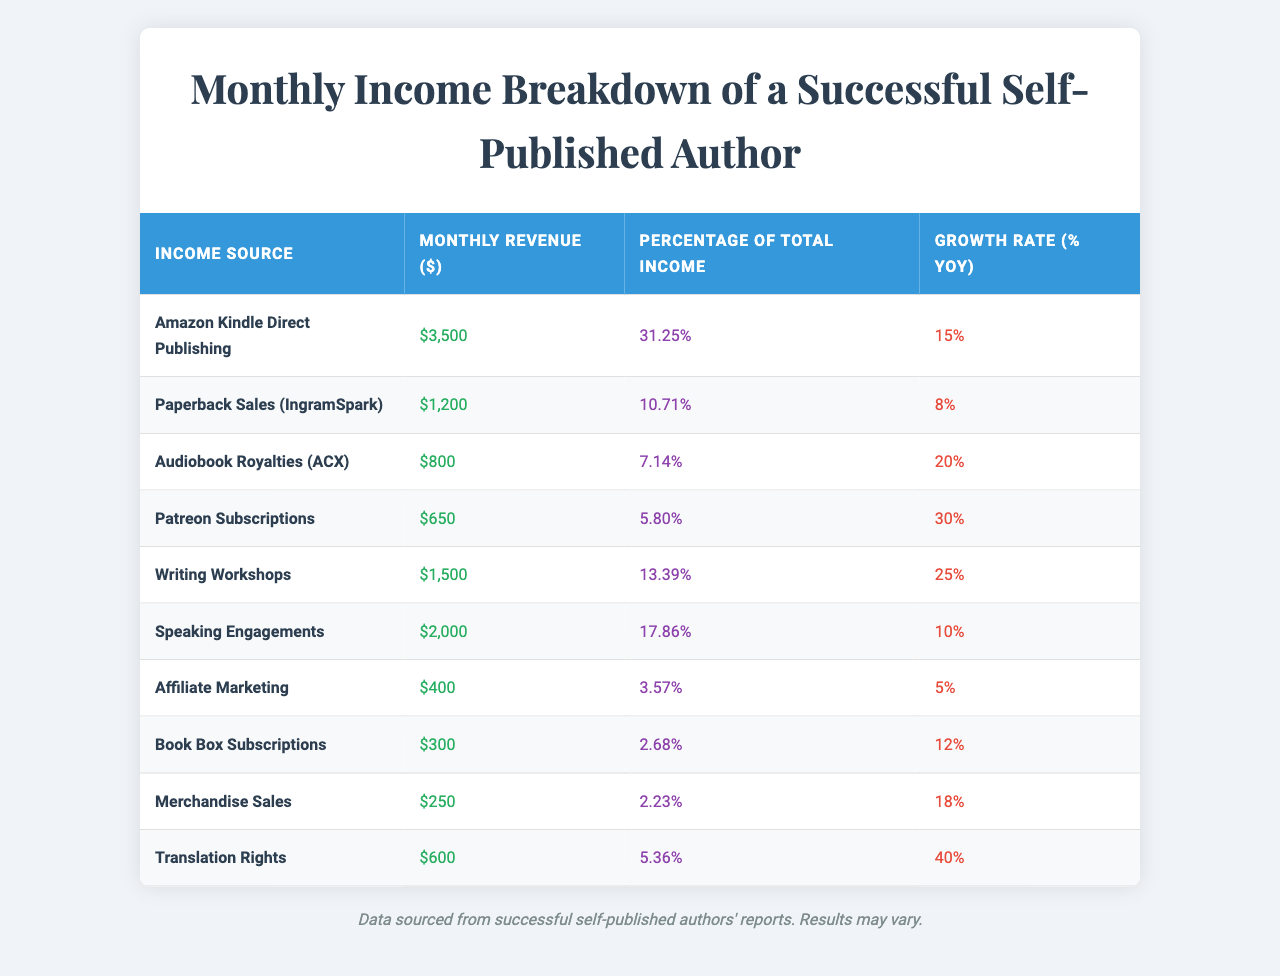What is the highest source of monthly revenue? The highest monthly revenue is listed under "Amazon Kindle Direct Publishing" with $3,500.
Answer: $3,500 What percentage of total income does "Speaking Engagements" represent? "Speaking Engagements" accounts for 17.86% of the total income.
Answer: 17.86% Which income source has the lowest monthly revenue? The income source with the lowest monthly revenue is "Translation Rights" at $600.
Answer: $600 What is the total monthly revenue from all sources? To find the total, we sum all monthly revenues: $3,500 + $1,200 + $800 + $650 + $1,500 + $2,000 + $400 + $300 + $250 + $600 = $12,200.
Answer: $12,200 Is the growth rate of "Patreon Subscriptions" higher than that of "Affiliate Marketing"? "Patreon Subscriptions" has a growth rate of 30%, while "Affiliate Marketing" has a rate of 5%. Thus, the statement is true.
Answer: Yes What is the average growth rate across all income sources? The average growth rate can be calculated by summing all growth rates: (15 + 8 + 20 + 30 + 25 + 10 + 5 + 12 + 18 + 40) =  188, and dividing by the number of sources (10): 188 / 10 = 18.8%.
Answer: 18.8% Which income source has a growth rate above 20%? The income sources with a growth rate above 20% are "Audiobook Royalties (ACX)" at 20%, "Patreon Subscriptions" at 30%, and "Writing Workshops" at 25%.
Answer: 3 sources How much does "Book Box Subscriptions" contribute to the total income in dollars? "Book Box Subscriptions" contributes $300 to the total income.
Answer: $300 What is the difference in monthly revenue between "Amazon Kindle Direct Publishing" and "Paperback Sales (IngramSpark)"? The difference is $3,500 - $1,200 = $2,300.
Answer: $2,300 Does the income from "Merchandise Sales" exceed 10% of total income? "Merchandise Sales" contributes $250, which is 2.23% of total income, so it does not exceed 10%.
Answer: No 